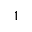<formula> <loc_0><loc_0><loc_500><loc_500>^ { 1 }</formula> 